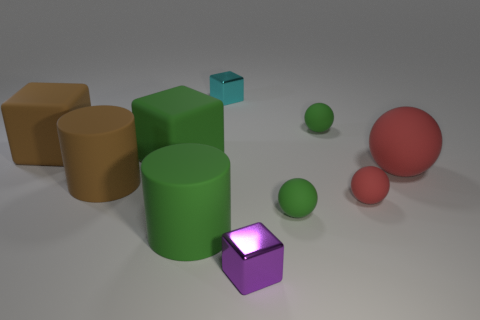Subtract 2 balls. How many balls are left? 2 Subtract all large spheres. How many spheres are left? 3 Subtract all brown balls. Subtract all yellow blocks. How many balls are left? 4 Subtract all cylinders. How many objects are left? 8 Add 8 large red rubber spheres. How many large red rubber spheres are left? 9 Add 7 large brown objects. How many large brown objects exist? 9 Subtract 1 purple cubes. How many objects are left? 9 Subtract all small things. Subtract all cylinders. How many objects are left? 3 